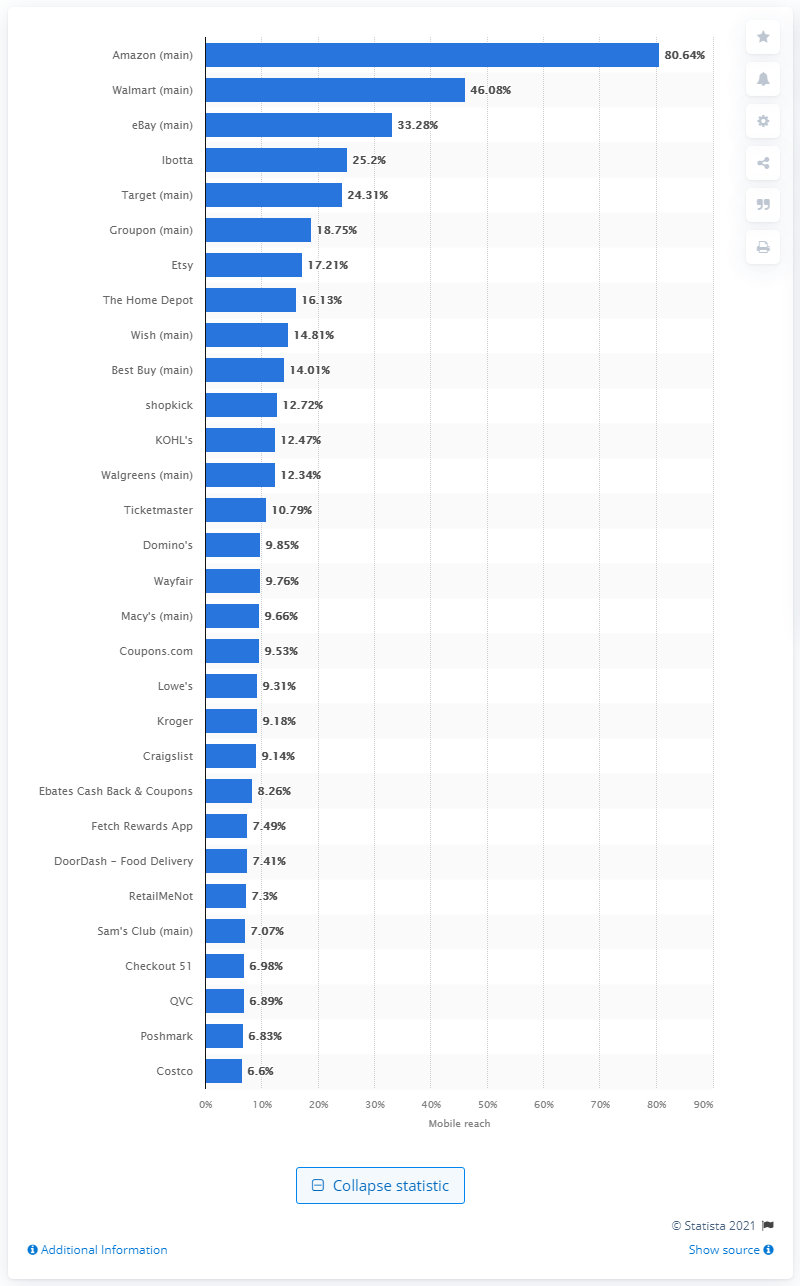Point out several critical features in this image. Walmart's mobile audience reach was 46.08 million people. 